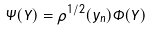<formula> <loc_0><loc_0><loc_500><loc_500>\Psi ( Y ) = \rho ^ { 1 / 2 } ( y _ { n } ) \Phi ( Y )</formula> 